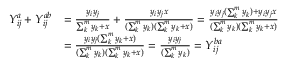Convert formula to latex. <formula><loc_0><loc_0><loc_500><loc_500>\begin{array} { r l } { Y _ { i j } ^ { a } + Y _ { i j } ^ { a b } } & { = \frac { y _ { i } y _ { j } } { \sum _ { k } ^ { m } y _ { k } + x } + \frac { y _ { i } y _ { j } x } { ( \sum _ { k } ^ { m } y _ { k } ) ( \sum _ { k } ^ { m } y _ { k } + x ) } = \frac { y _ { i } y _ { j } ( \sum _ { k } ^ { m } y _ { k } ) + y _ { i } y _ { j } x } { ( \sum _ { k } ^ { m } y _ { k } ) ( \sum _ { k } ^ { m } y _ { k } + x ) } } \\ & { = \frac { y _ { i } y _ { j } ( \sum _ { k } ^ { m } y _ { k } + x ) } { ( \sum _ { k } ^ { m } y _ { k } ) ( \sum _ { k } ^ { m } y _ { k } + x ) } = \frac { y _ { i } y _ { j } } { ( \sum _ { k } ^ { m } y _ { k } ) } = Y _ { i j } ^ { b a } } \end{array}</formula> 